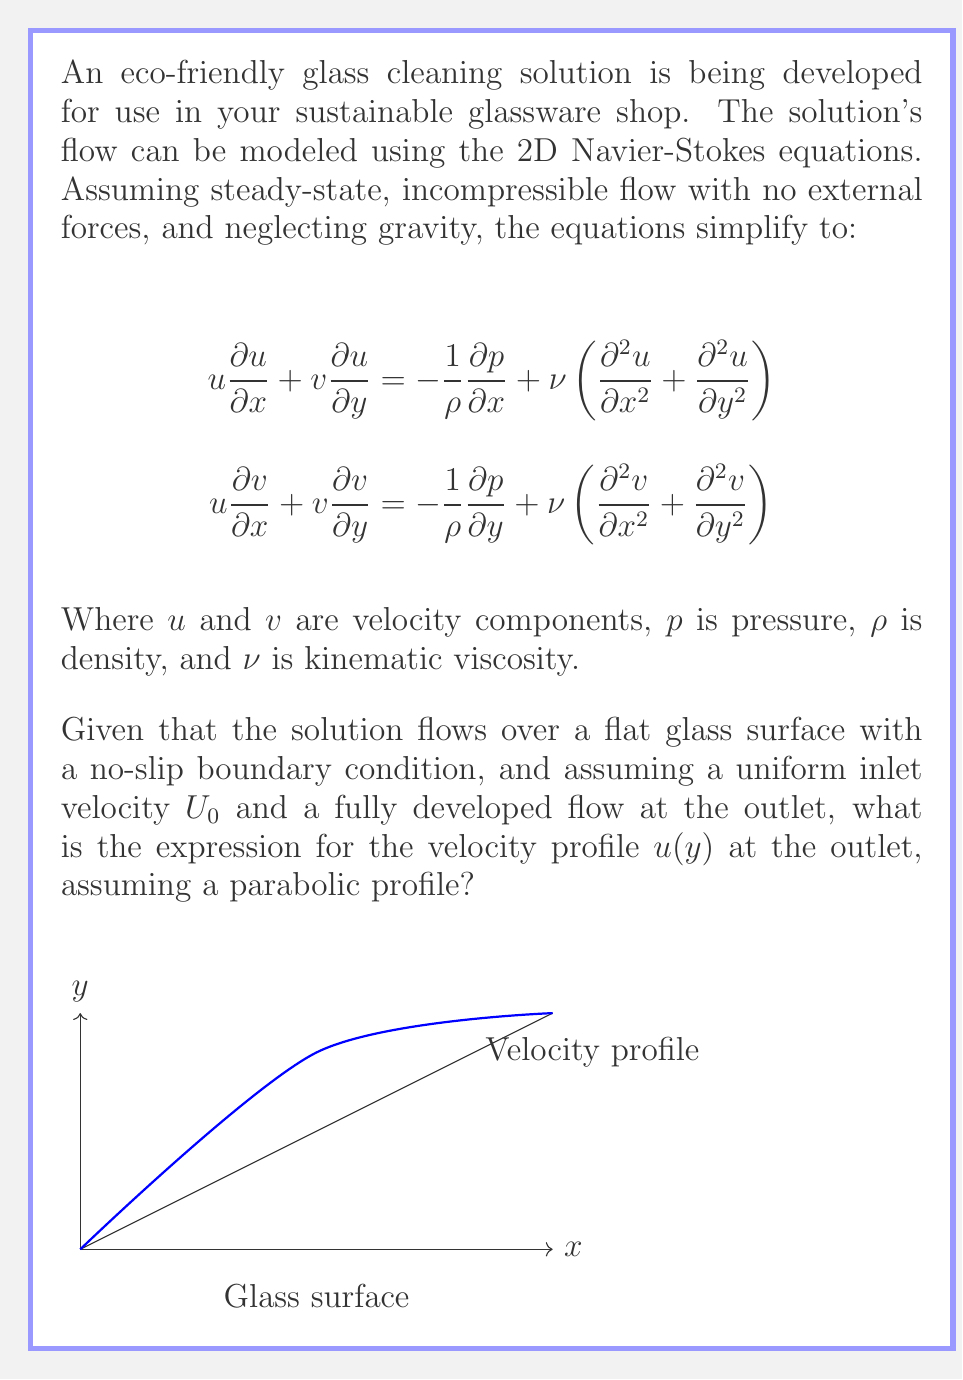Can you solve this math problem? To solve this problem, we'll follow these steps:

1) For a fully developed flow at the outlet, the velocity doesn't change in the x-direction. Thus, $\frac{\partial u}{\partial x} = 0$.

2) The continuity equation for incompressible flow is $\frac{\partial u}{\partial x} + \frac{\partial v}{\partial y} = 0$. Since $\frac{\partial u}{\partial x} = 0$, we also have $\frac{\partial v}{\partial y} = 0$.

3) With these simplifications, the x-component of the Navier-Stokes equation becomes:

   $$0 = -\frac{1}{\rho}\frac{\partial p}{\partial x} + \nu\frac{\partial^2 u}{\partial y^2}$$

4) The pressure gradient $\frac{\partial p}{\partial x}$ is constant for fully developed flow. Let's call this constant $-K$. Then:

   $$\frac{\nu}{\rho}\frac{\partial^2 u}{\partial y^2} = -\frac{K}{\rho}$$

5) Integrating twice with respect to y:

   $$u(y) = -\frac{K}{2\nu\rho}y^2 + C_1y + C_2$$

6) This is a parabolic profile. To determine the constants, we use the boundary conditions:
   - No-slip at the wall: $u(0) = 0$
   - Maximum velocity at the center: $\frac{du}{dy}(h/2) = 0$, where $h$ is the channel height

7) Applying these conditions:
   - $u(0) = 0$ gives $C_2 = 0$
   - $\frac{du}{dy}(h/2) = -\frac{K}{\nu\rho}\frac{h}{2} + C_1 = 0$ gives $C_1 = \frac{Kh}{2\nu\rho}$

8) Substituting back:

   $$u(y) = -\frac{K}{2\nu\rho}y^2 + \frac{Kh}{2\nu\rho}y$$

9) The maximum velocity $u_{max}$ occurs at $y = h/2$. Substituting this:

   $$u_{max} = \frac{Kh^2}{8\nu\rho}$$

10) We can express the profile in terms of $u_{max}$:

    $$u(y) = 4u_{max}\frac{y}{h}\left(1 - \frac{y}{h}\right)$$

This is the final expression for the parabolic velocity profile.
Answer: $u(y) = 4u_{max}\frac{y}{h}\left(1 - \frac{y}{h}\right)$ 